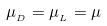Convert formula to latex. <formula><loc_0><loc_0><loc_500><loc_500>\mu _ { _ { D } } = \mu _ { _ { L } } = \mu</formula> 